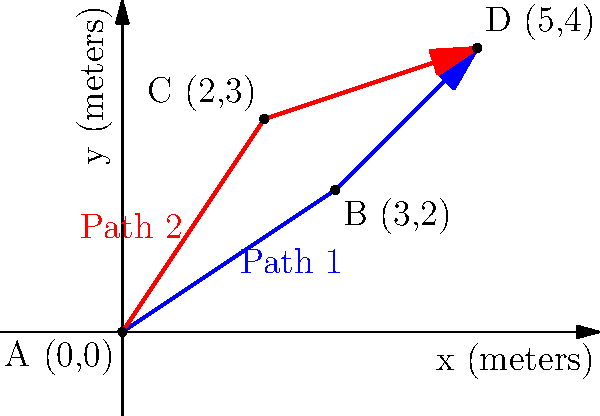In a manufacturing facility, two potential workflow paths from point A to point D are being analyzed for optimization. Path 1 goes through point B, while Path 2 goes through point C. Using vector coordinates, calculate the difference in total distance traveled between Path 1 and Path 2. Which path is shorter, and by how many meters? To solve this problem, we'll follow these steps:

1. Calculate the vectors for each segment of Path 1 and Path 2.
2. Find the magnitude (length) of each vector.
3. Sum the magnitudes for each path to get the total distance.
4. Compare the total distances.

Path 1: A → B → D
Path 2: A → C → D

Step 1: Calculate vectors

Path 1:
Vector AB = (3-0, 2-0) = (3, 2)
Vector BD = (5-3, 4-2) = (2, 2)

Path 2:
Vector AC = (2-0, 3-0) = (2, 3)
Vector CD = (5-2, 4-3) = (3, 1)

Step 2: Find magnitudes

For a vector (x, y), magnitude = $\sqrt{x^2 + y^2}$

Path 1:
|AB| = $\sqrt{3^2 + 2^2} = \sqrt{13}$
|BD| = $\sqrt{2^2 + 2^2} = \sqrt{8} = 2\sqrt{2}$

Path 2:
|AC| = $\sqrt{2^2 + 3^2} = \sqrt{13}$
|CD| = $\sqrt{3^2 + 1^2} = \sqrt{10}$

Step 3: Sum magnitudes

Path 1 total distance = $\sqrt{13} + 2\sqrt{2}$ ≈ 6.45 meters
Path 2 total distance = $\sqrt{13} + \sqrt{10}$ ≈ 6.80 meters

Step 4: Compare distances

Difference = Path 2 - Path 1
           = $(\sqrt{13} + \sqrt{10}) - (\sqrt{13} + 2\sqrt{2})$
           = $\sqrt{10} - 2\sqrt{2}$
           ≈ 0.35 meters

Therefore, Path 1 is shorter than Path 2 by approximately 0.35 meters.
Answer: Path 1 is shorter by 0.35 meters. 